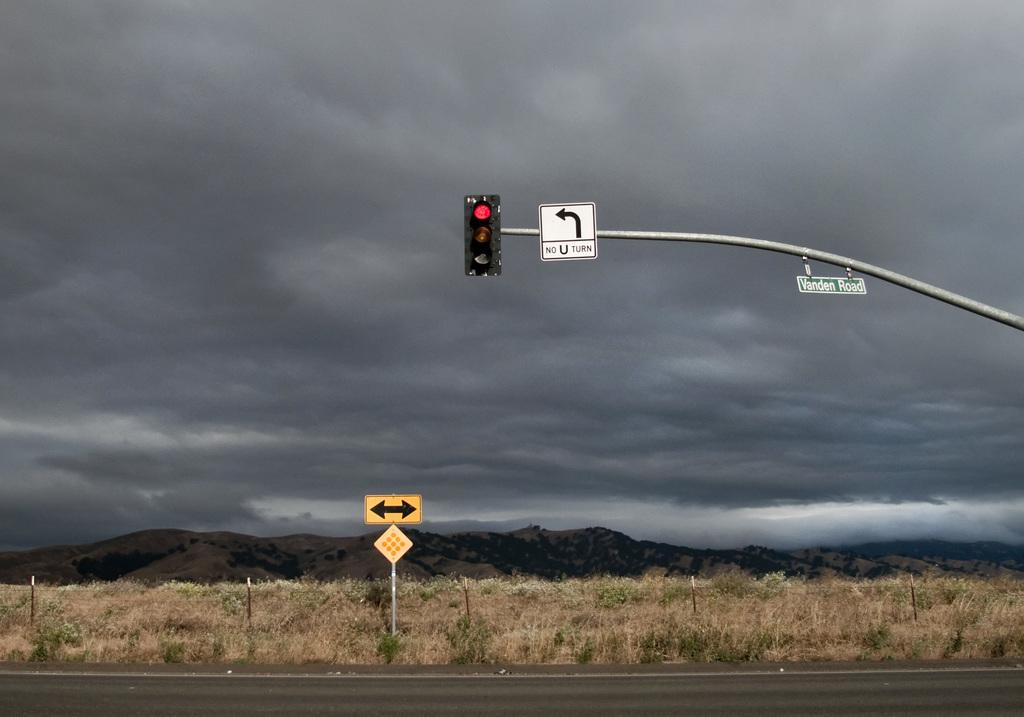<image>
Relay a brief, clear account of the picture shown. dark cloudy day at an intersection and a red light and a no u turn sign 